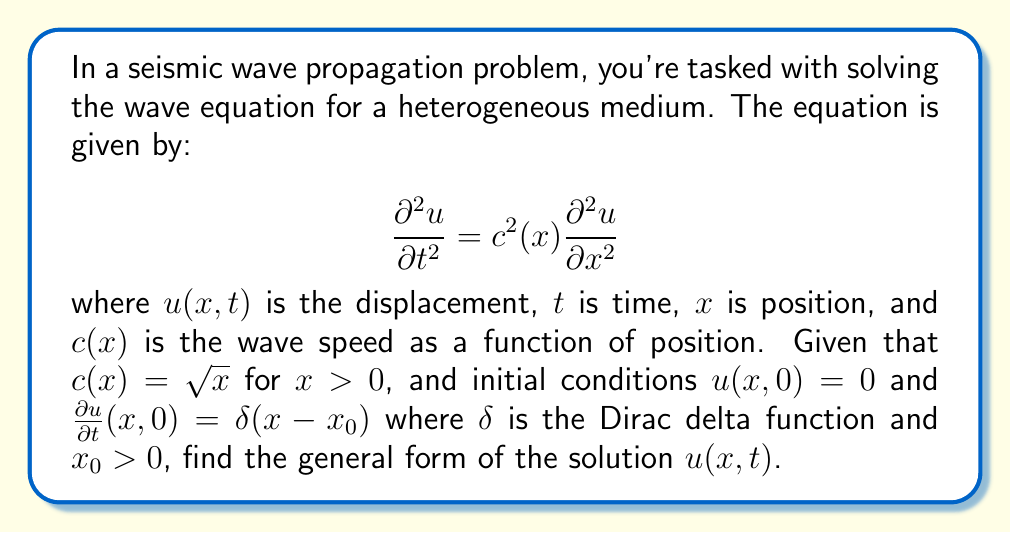Can you answer this question? To solve this wave equation for a heterogeneous medium, we'll follow these steps:

1) First, we need to transform the equation to remove the variable coefficient. Let's introduce a new spatial variable $\xi$ such that:

   $$\xi = \int_0^x \frac{1}{c(s)} ds = \int_0^x \frac{1}{\sqrt{s}} ds = 2\sqrt{x}$$

2) This transformation leads to:

   $$\frac{\partial x}{\partial \xi} = \frac{\xi}{2}$$

3) Now, we can rewrite the wave equation in terms of $\xi$:

   $$\frac{\partial^2 u}{\partial t^2} = \frac{\partial^2 u}{\partial \xi^2}$$

4) This is now a standard wave equation with constant coefficients, which has the general solution:

   $$u(\xi,t) = f(\xi - t) + g(\xi + t)$$

   where $f$ and $g$ are arbitrary functions determined by the initial conditions.

5) Transforming back to the original variables:

   $$u(x,t) = f(2\sqrt{x} - t) + g(2\sqrt{x} + t)$$

6) To determine $f$ and $g$, we use the initial conditions. The condition $u(x,0) = 0$ implies:

   $$f(2\sqrt{x}) + g(2\sqrt{x}) = 0$$

   or $g(\xi) = -f(\xi)$

7) The second condition, $\frac{\partial u}{\partial t}(x,0) = \delta(x-x_0)$, in the transformed coordinates becomes:

   $$-f'(2\sqrt{x}) + g'(2\sqrt{x}) = \frac{1}{2\sqrt{x}}\delta(x-x_0)$$

8) Using the result from step 6, this becomes:

   $$-2f'(2\sqrt{x}) = \frac{1}{2\sqrt{x}}\delta(x-x_0)$$

9) Integrating both sides with respect to $x$:

   $$f(2\sqrt{x}) = -\frac{1}{4}\text{H}(x-x_0)$$

   where $\text{H}$ is the Heaviside step function.

10) Therefore, the general solution is:

    $$u(x,t) = \frac{1}{4}[\text{H}(2\sqrt{x_0} - (2\sqrt{x} - t)) - \text{H}(2\sqrt{x_0} - (2\sqrt{x} + t))]$$
Answer: $u(x,t) = \frac{1}{4}[\text{H}(2\sqrt{x_0} - (2\sqrt{x} - t)) - \text{H}(2\sqrt{x_0} - (2\sqrt{x} + t))]$ 